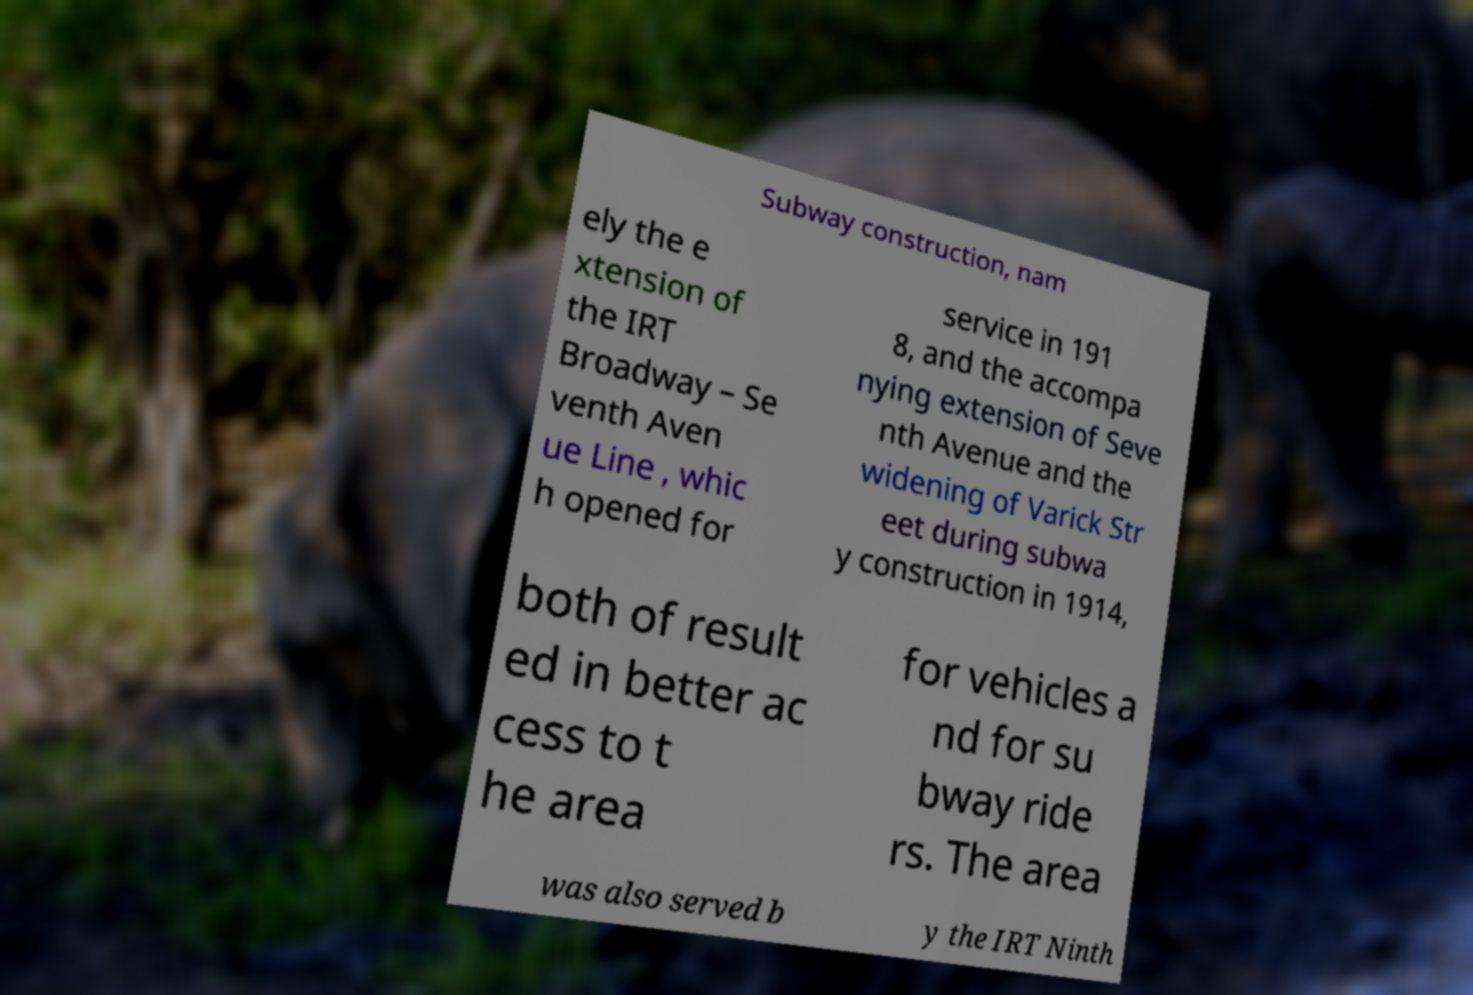Could you extract and type out the text from this image? Subway construction, nam ely the e xtension of the IRT Broadway – Se venth Aven ue Line , whic h opened for service in 191 8, and the accompa nying extension of Seve nth Avenue and the widening of Varick Str eet during subwa y construction in 1914, both of result ed in better ac cess to t he area for vehicles a nd for su bway ride rs. The area was also served b y the IRT Ninth 